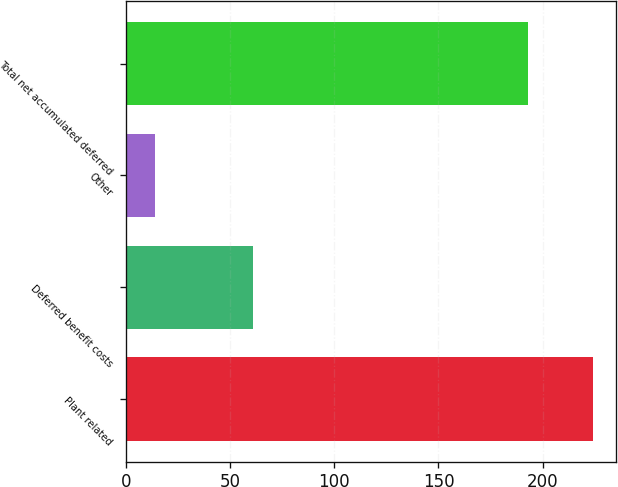Convert chart. <chart><loc_0><loc_0><loc_500><loc_500><bar_chart><fcel>Plant related<fcel>Deferred benefit costs<fcel>Other<fcel>Total net accumulated deferred<nl><fcel>224<fcel>61<fcel>14<fcel>193<nl></chart> 